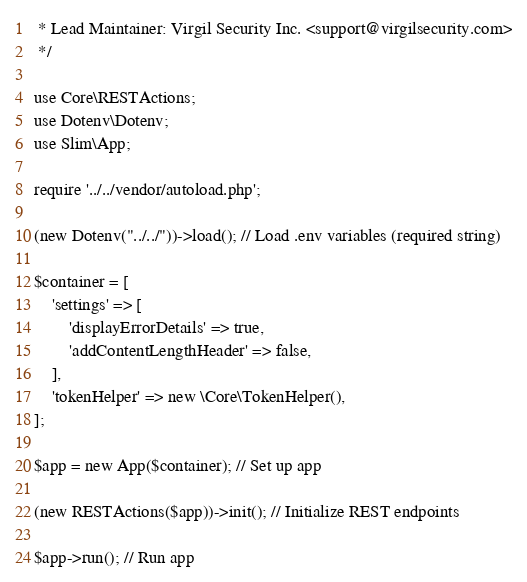<code> <loc_0><loc_0><loc_500><loc_500><_PHP_> * Lead Maintainer: Virgil Security Inc. <support@virgilsecurity.com>
 */

use Core\RESTActions;
use Dotenv\Dotenv;
use Slim\App;

require '../../vendor/autoload.php';

(new Dotenv("../../"))->load(); // Load .env variables (required string)

$container = [
    'settings' => [
        'displayErrorDetails' => true,
        'addContentLengthHeader' => false,
    ],
    'tokenHelper' => new \Core\TokenHelper(),
];

$app = new App($container); // Set up app

(new RESTActions($app))->init(); // Initialize REST endpoints

$app->run(); // Run app
</code> 